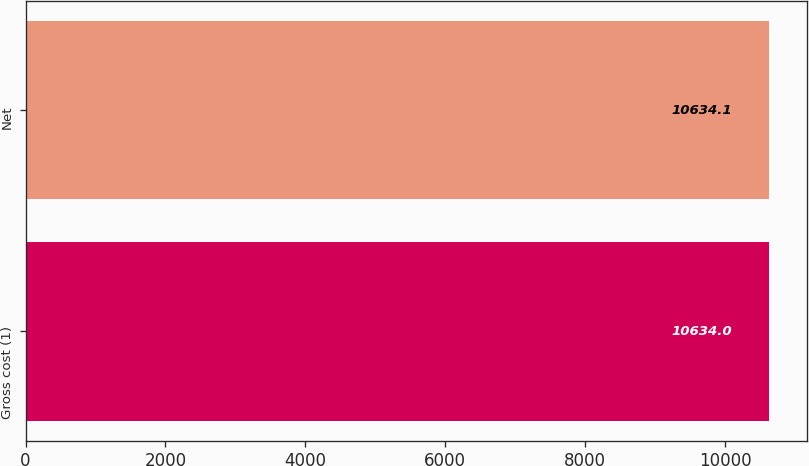Convert chart. <chart><loc_0><loc_0><loc_500><loc_500><bar_chart><fcel>Gross cost (1)<fcel>Net<nl><fcel>10634<fcel>10634.1<nl></chart> 